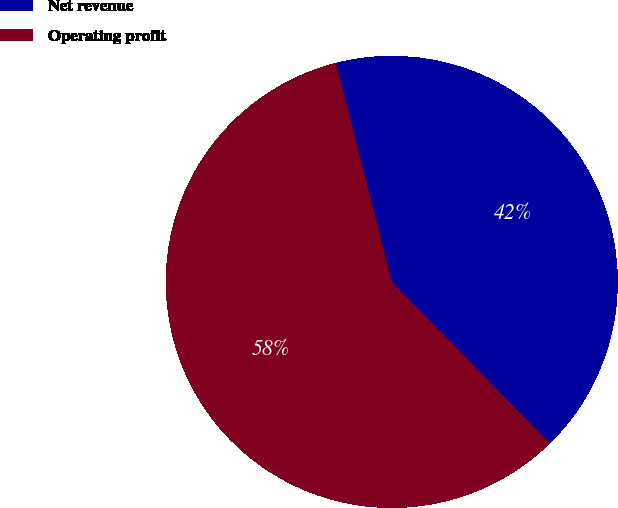Convert chart. <chart><loc_0><loc_0><loc_500><loc_500><pie_chart><fcel>Net revenue<fcel>Operating profit<nl><fcel>41.67%<fcel>58.33%<nl></chart> 